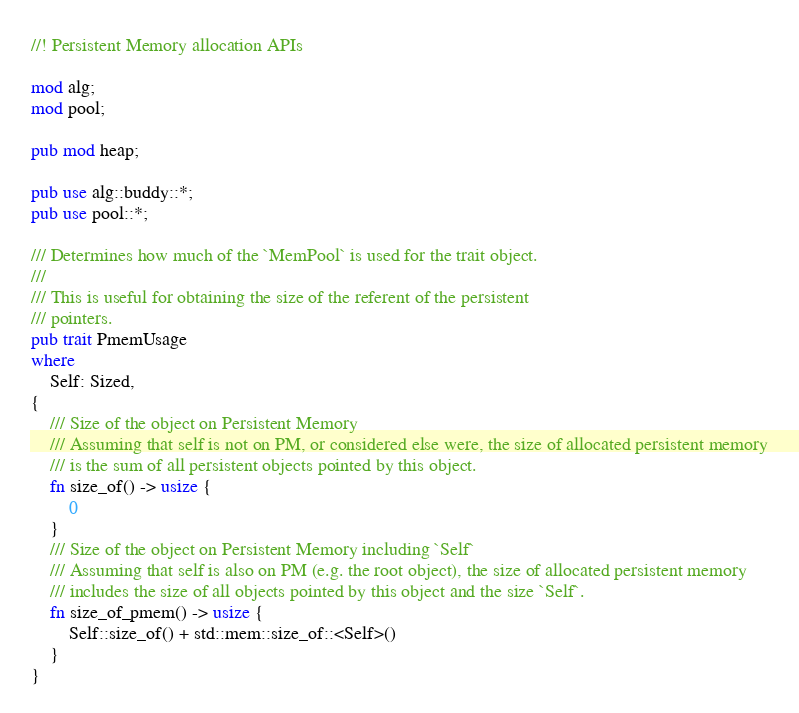<code> <loc_0><loc_0><loc_500><loc_500><_Rust_>//! Persistent Memory allocation APIs

mod alg;
mod pool;

pub mod heap;

pub use alg::buddy::*;
pub use pool::*;

/// Determines how much of the `MemPool` is used for the trait object.
///
/// This is useful for obtaining the size of the referent of the persistent
/// pointers.
pub trait PmemUsage
where
    Self: Sized,
{
    /// Size of the object on Persistent Memory
    /// Assuming that self is not on PM, or considered else were, the size of allocated persistent memory
    /// is the sum of all persistent objects pointed by this object.
    fn size_of() -> usize {
        0
    }
    /// Size of the object on Persistent Memory including `Self`
    /// Assuming that self is also on PM (e.g. the root object), the size of allocated persistent memory
    /// includes the size of all objects pointed by this object and the size `Self`.
    fn size_of_pmem() -> usize {
        Self::size_of() + std::mem::size_of::<Self>()
    }
}
</code> 